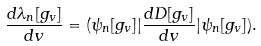<formula> <loc_0><loc_0><loc_500><loc_500>\frac { d \lambda _ { n } [ g _ { v } ] } { d v } = ( \psi _ { n } [ g _ { v } ] | \frac { d D [ g _ { v } ] } { d v } | \psi _ { n } [ g _ { v } ] ) .</formula> 